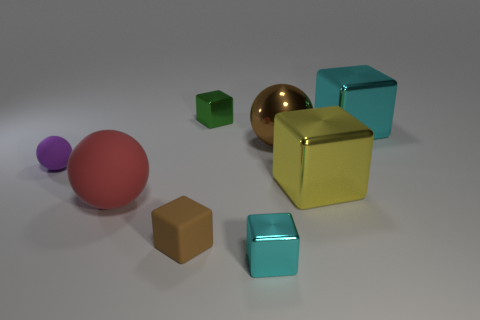Are the small brown object and the small purple thing made of the same material?
Ensure brevity in your answer.  Yes. The large yellow shiny object that is on the right side of the small metal cube in front of the small thing that is behind the purple sphere is what shape?
Make the answer very short. Cube. Is the number of small spheres on the right side of the tiny purple object less than the number of objects that are behind the large cyan cube?
Offer a terse response. Yes. There is a cyan object behind the large block that is in front of the purple matte ball; what shape is it?
Keep it short and to the point. Cube. Is there anything else that has the same color as the tiny matte cube?
Your answer should be very brief. Yes. Is the color of the metal ball the same as the rubber cube?
Provide a short and direct response. Yes. What number of gray things are small matte balls or cubes?
Give a very brief answer. 0. Is the number of large brown shiny things that are on the right side of the brown ball less than the number of small green shiny things?
Your response must be concise. Yes. There is a small shiny object behind the small brown rubber object; how many big balls are right of it?
Provide a succinct answer. 1. What number of other things are there of the same size as the yellow cube?
Your answer should be very brief. 3. 